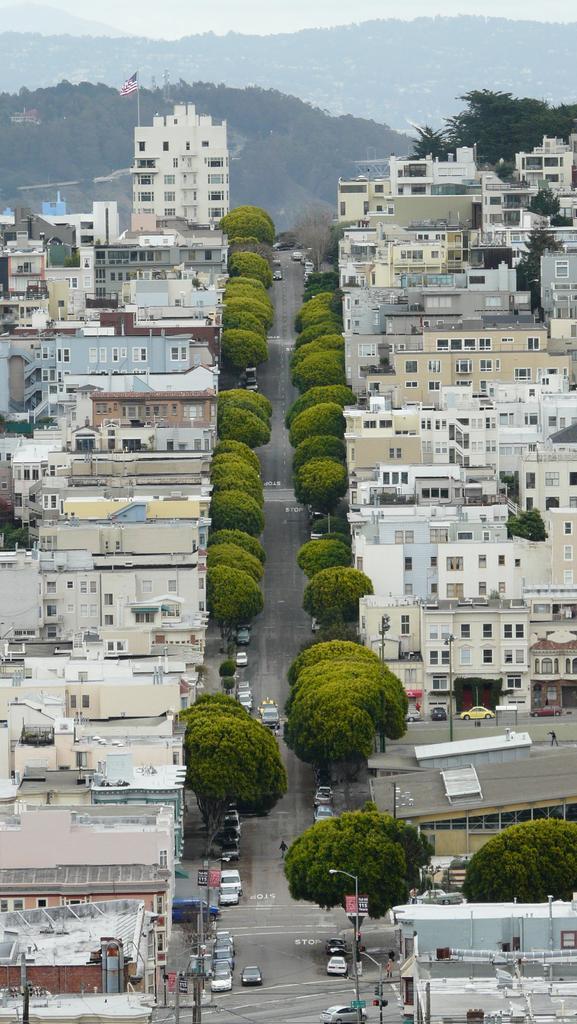How would you summarize this image in a sentence or two? This is an aerial view in this image, there are buildings, trees, cars on the road, in the background there are mountains and there is a flag on one building. 